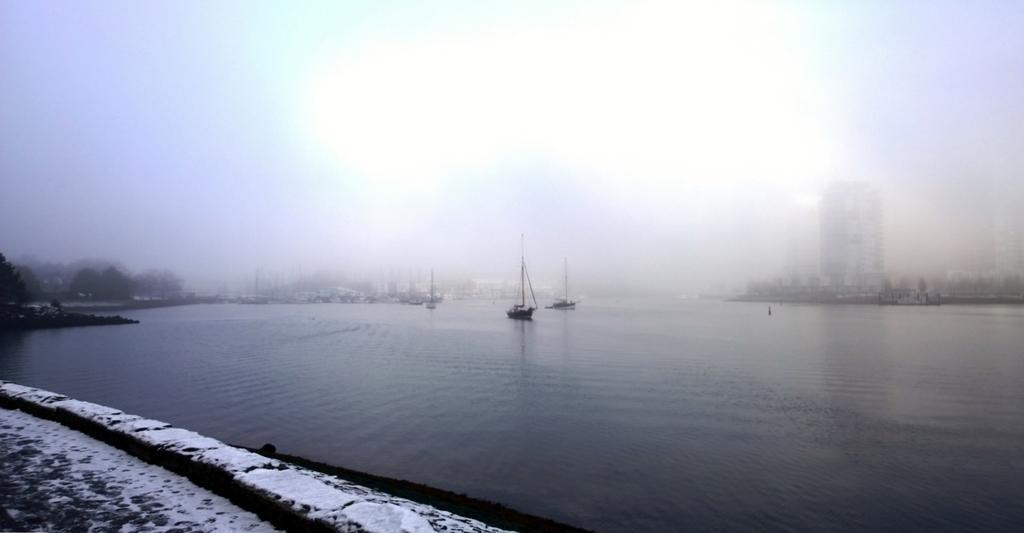In one or two sentences, can you explain what this image depicts? In this image, we can see boats are above the water. At the bottom of the image, we can see a walkway and snow. In the background, there are boats, trees, building and fog 